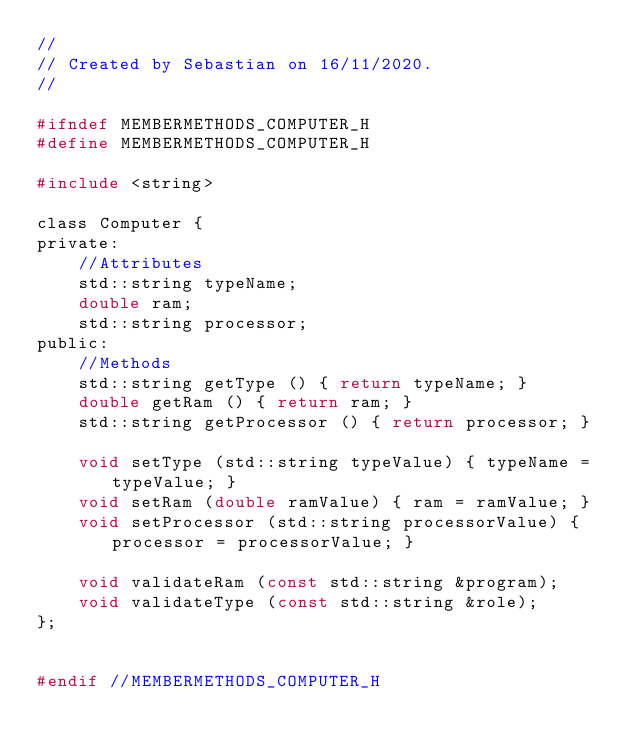<code> <loc_0><loc_0><loc_500><loc_500><_C_>//
// Created by Sebastian on 16/11/2020.
//

#ifndef MEMBERMETHODS_COMPUTER_H
#define MEMBERMETHODS_COMPUTER_H

#include <string>

class Computer {
private:
    //Attributes
    std::string typeName;
    double ram;
    std::string processor;
public:
    //Methods
    std::string getType () { return typeName; }
    double getRam () { return ram; }
    std::string getProcessor () { return processor; }

    void setType (std::string typeValue) { typeName = typeValue; }
    void setRam (double ramValue) { ram = ramValue; }
    void setProcessor (std::string processorValue) { processor = processorValue; }

    void validateRam (const std::string &program);
    void validateType (const std::string &role);
};


#endif //MEMBERMETHODS_COMPUTER_H
</code> 